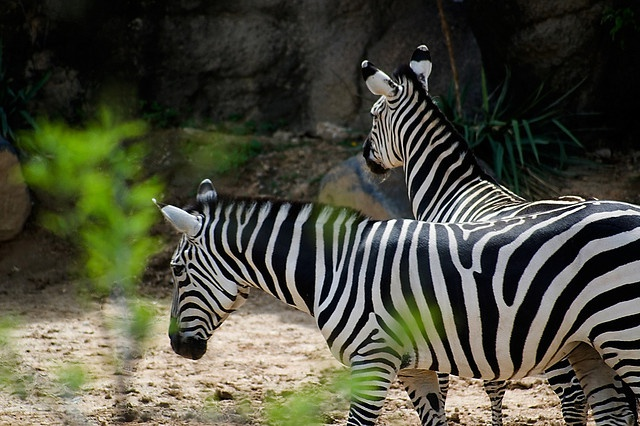Describe the objects in this image and their specific colors. I can see zebra in black, darkgray, and gray tones and zebra in black, darkgray, gray, and lightgray tones in this image. 